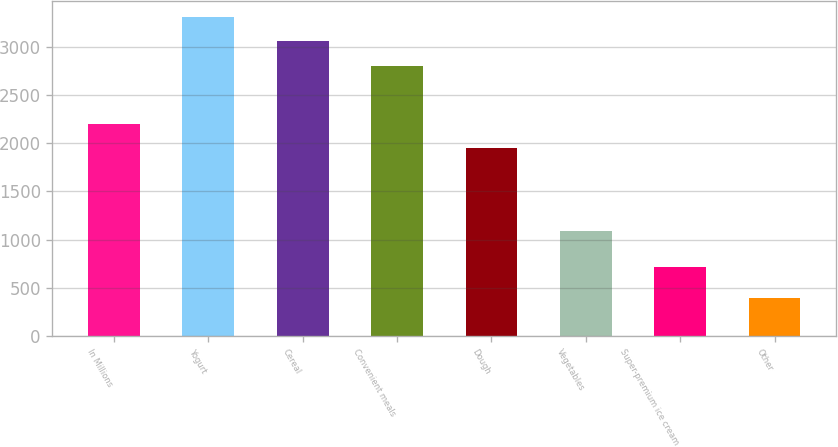Convert chart. <chart><loc_0><loc_0><loc_500><loc_500><bar_chart><fcel>In Millions<fcel>Yogurt<fcel>Cereal<fcel>Convenient meals<fcel>Dough<fcel>Vegetables<fcel>Super-premium ice cream<fcel>Other<nl><fcel>2195.66<fcel>3304.82<fcel>3053.86<fcel>2802.9<fcel>1944.7<fcel>1089.5<fcel>717.1<fcel>398.8<nl></chart> 